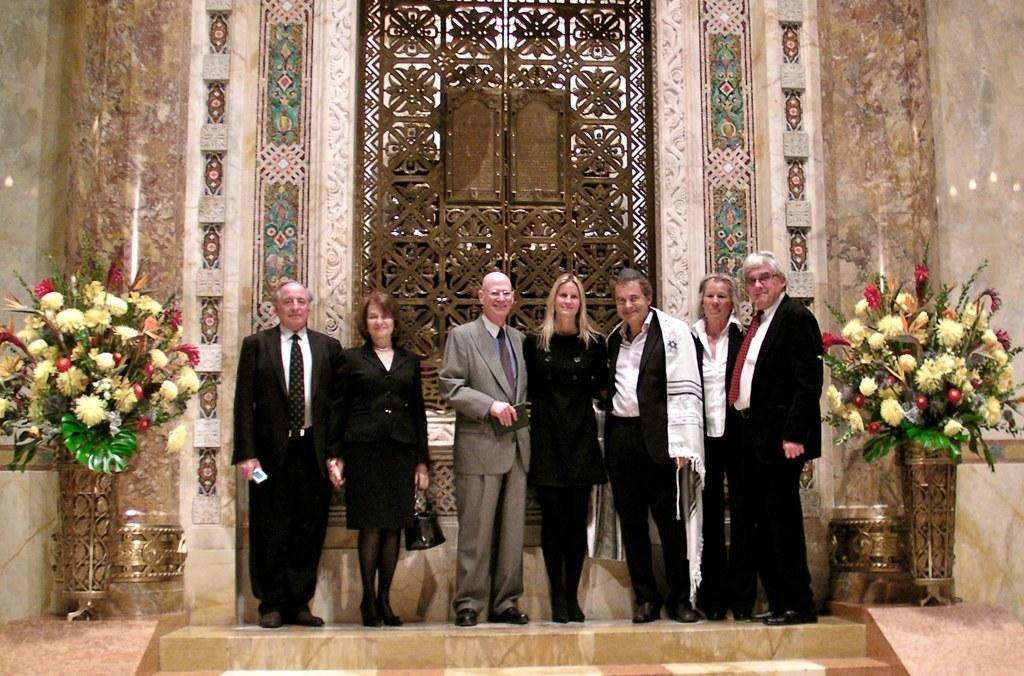How many people are in the image? There are two women and five men in the image, making a total of seven people. What are the people doing in the image? The people are standing in front of a wall. Can you describe the surroundings of the image? Flowers are present on both sides of the image. What type of mist can be seen surrounding the people in the image? There is no mist present in the image; the people are standing in front of a wall with flowers on both sides. What is being exchanged between the people in the image? There is no indication of an exchange between the people in the image; they are simply standing in front of a wall. 